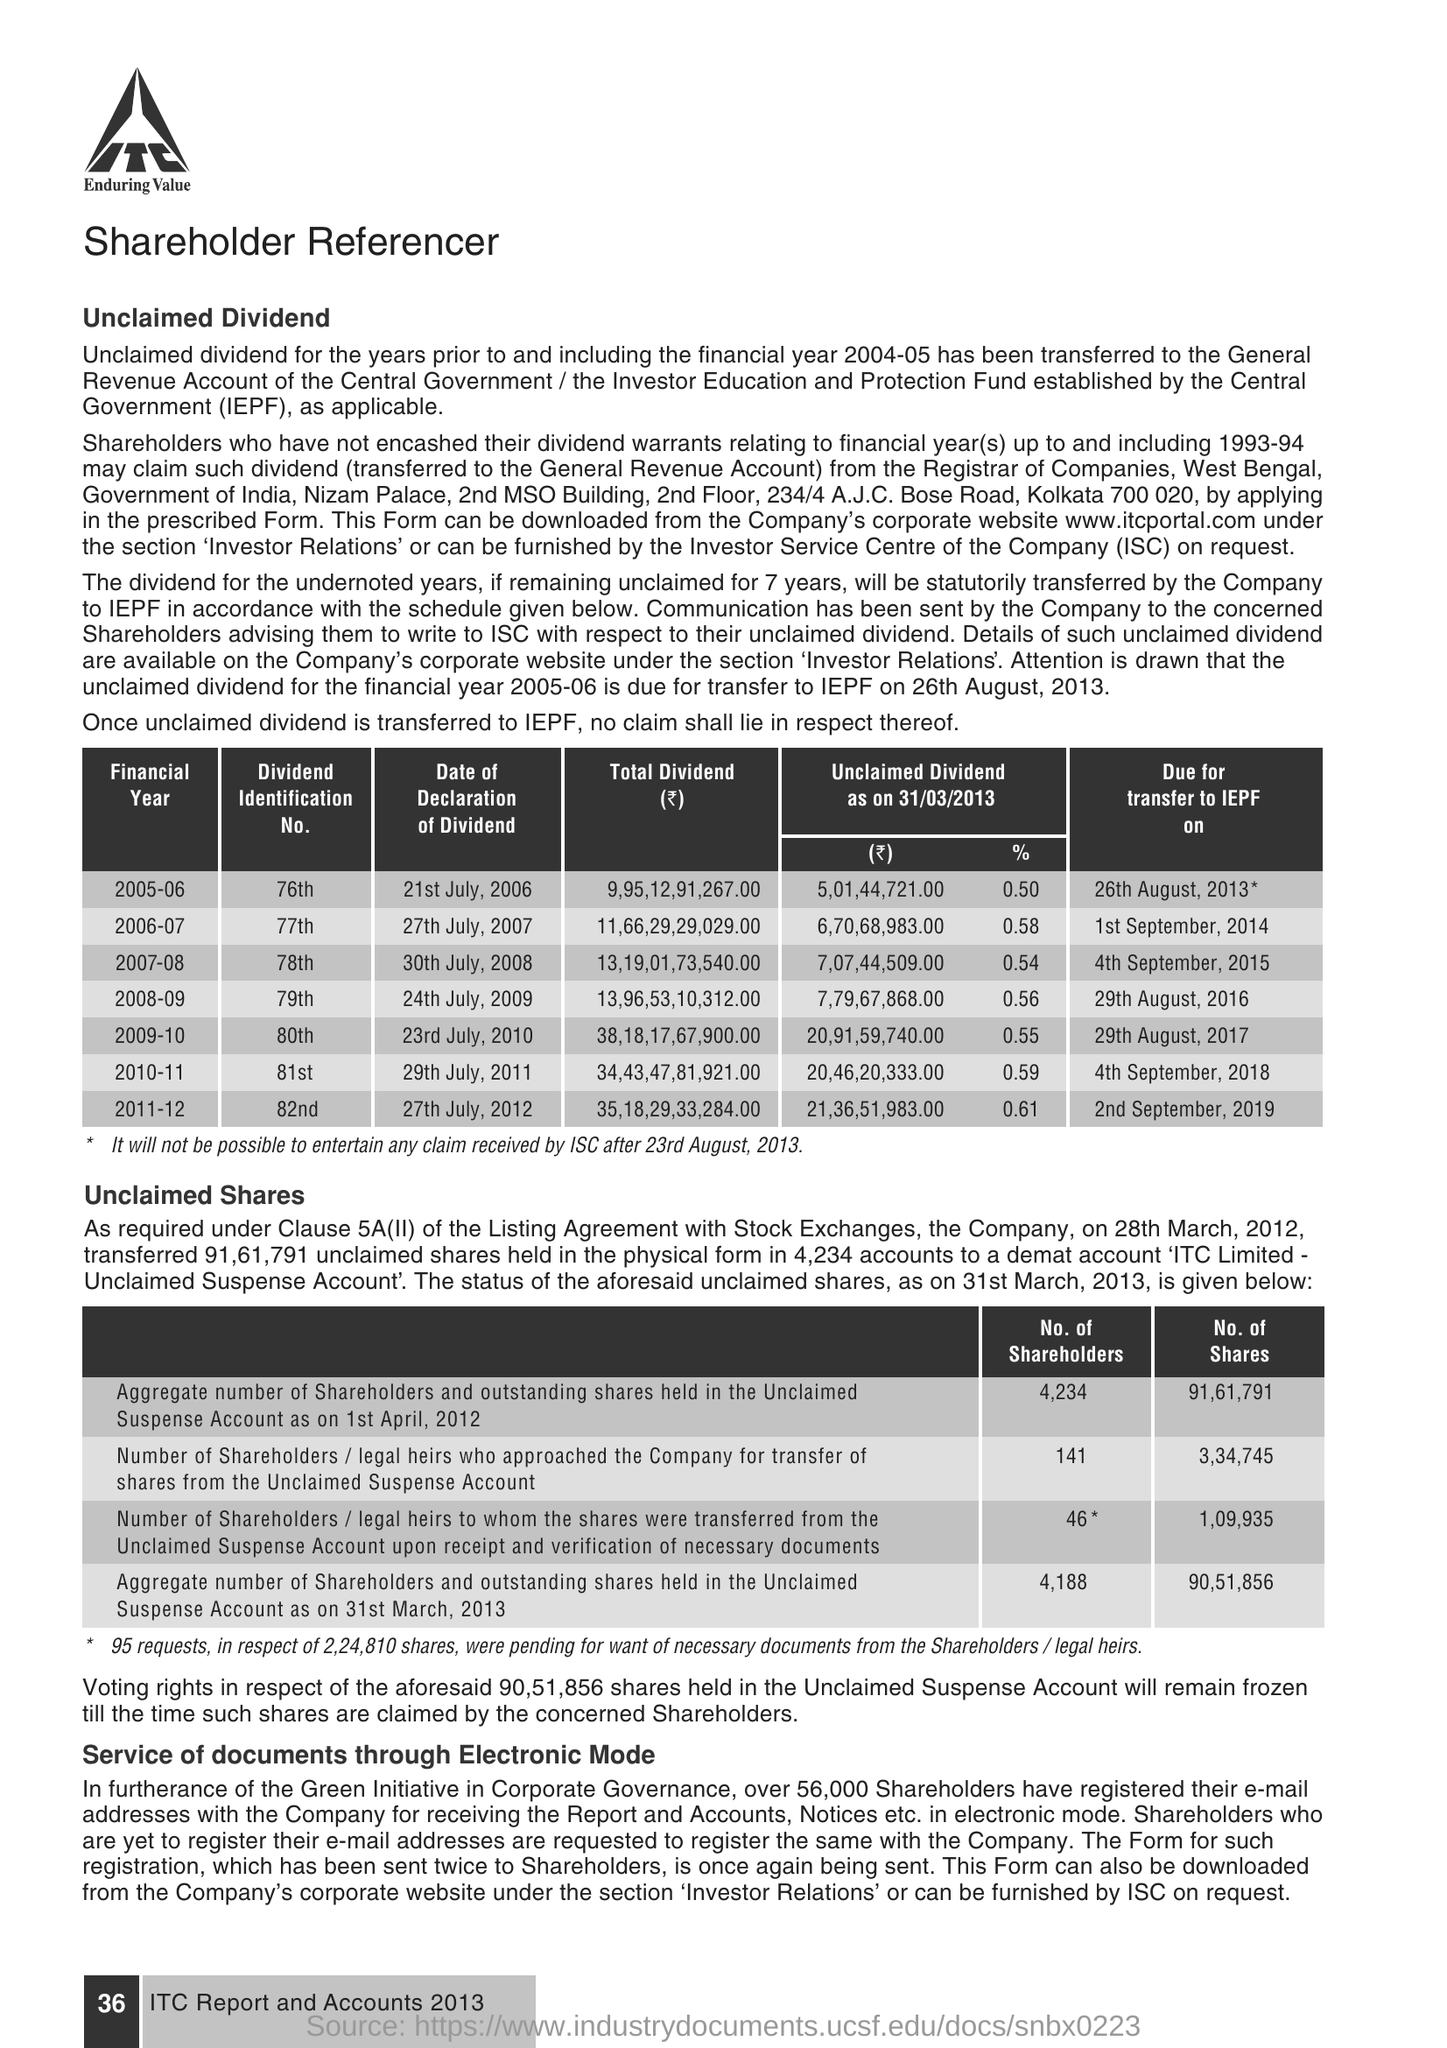List a handful of essential elements in this visual. The divided identification number for the financial year 2009-10 is 80. On July 24, 2009, the date of declaration of dividend for the financial year 2008-09 was announced. The acronym 'IEPF' stands for 'Investor Education and Protection Fund', which is a fund established to educate and protect the interests of investors in India. 